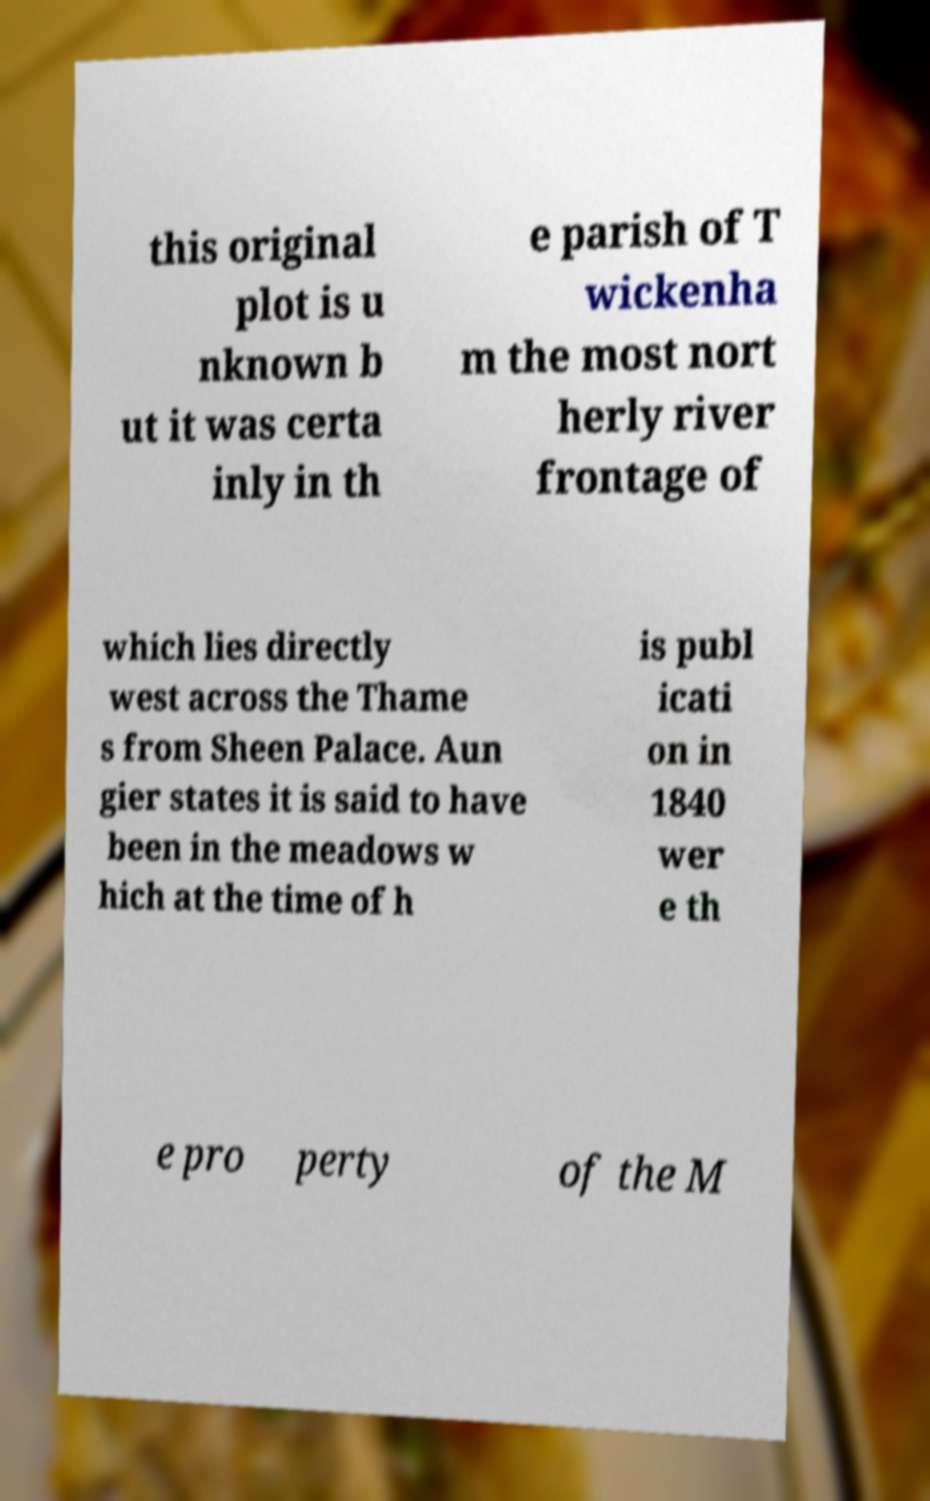For documentation purposes, I need the text within this image transcribed. Could you provide that? this original plot is u nknown b ut it was certa inly in th e parish of T wickenha m the most nort herly river frontage of which lies directly west across the Thame s from Sheen Palace. Aun gier states it is said to have been in the meadows w hich at the time of h is publ icati on in 1840 wer e th e pro perty of the M 